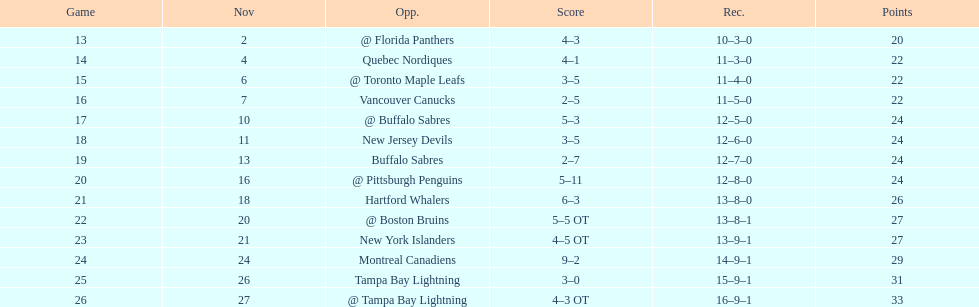The 1993-1994 flyers missed the playoffs again. how many consecutive seasons up until 93-94 did the flyers miss the playoffs? 5. 